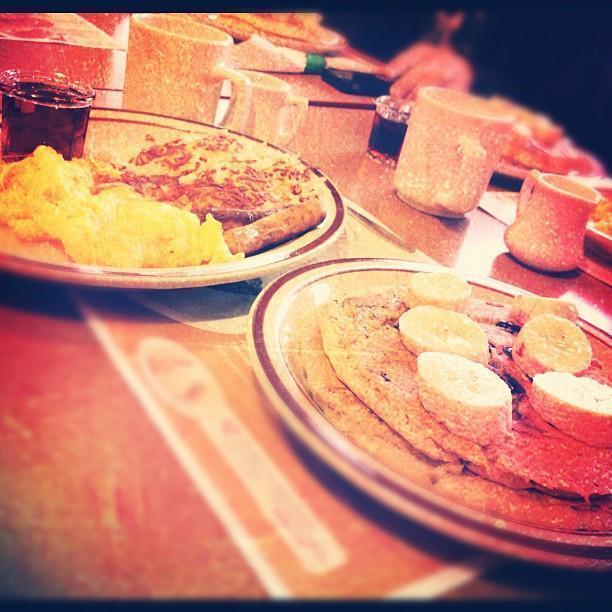What color are the fruits sliced out on top of the pancake?
Indicate the correct response by choosing from the four available options to answer the question.
Options: Blue, pink, white, red. White. 